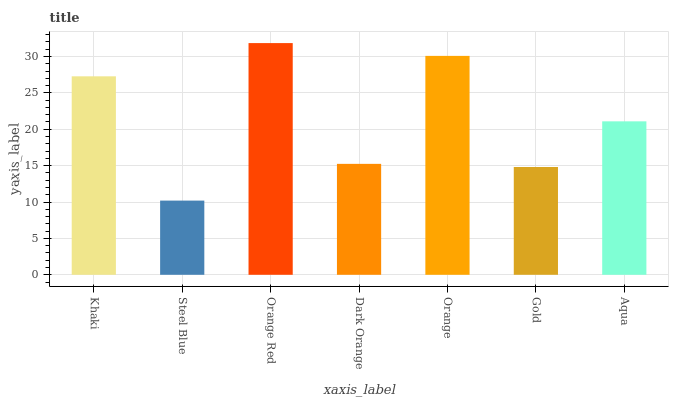Is Steel Blue the minimum?
Answer yes or no. Yes. Is Orange Red the maximum?
Answer yes or no. Yes. Is Orange Red the minimum?
Answer yes or no. No. Is Steel Blue the maximum?
Answer yes or no. No. Is Orange Red greater than Steel Blue?
Answer yes or no. Yes. Is Steel Blue less than Orange Red?
Answer yes or no. Yes. Is Steel Blue greater than Orange Red?
Answer yes or no. No. Is Orange Red less than Steel Blue?
Answer yes or no. No. Is Aqua the high median?
Answer yes or no. Yes. Is Aqua the low median?
Answer yes or no. Yes. Is Orange the high median?
Answer yes or no. No. Is Orange Red the low median?
Answer yes or no. No. 